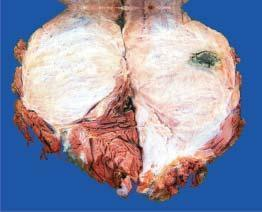s the covering mucosa grey-white fleshy with areas of haemorrhage and necrosis?
Answer the question using a single word or phrase. No 